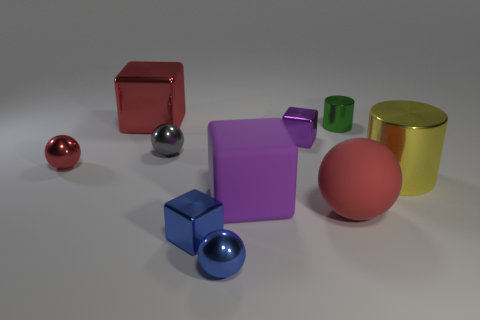Can you describe the lighting and atmosphere of the scene where these objects are placed? The image presents a soft, diffused lighting that creates gentle shadows and gives the scene a calm, almost studio-like atmosphere. The neutral grey background does not distract from the objects, which are the focal point. 